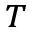<formula> <loc_0><loc_0><loc_500><loc_500>_ { T }</formula> 